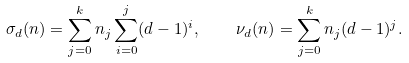<formula> <loc_0><loc_0><loc_500><loc_500>\sigma _ { d } ( n ) = \sum _ { j = 0 } ^ { k } n _ { j } \sum _ { i = 0 } ^ { j } ( d - 1 ) ^ { i } , \quad \nu _ { d } ( n ) = \sum _ { j = 0 } ^ { k } n _ { j } ( d - 1 ) ^ { j } .</formula> 